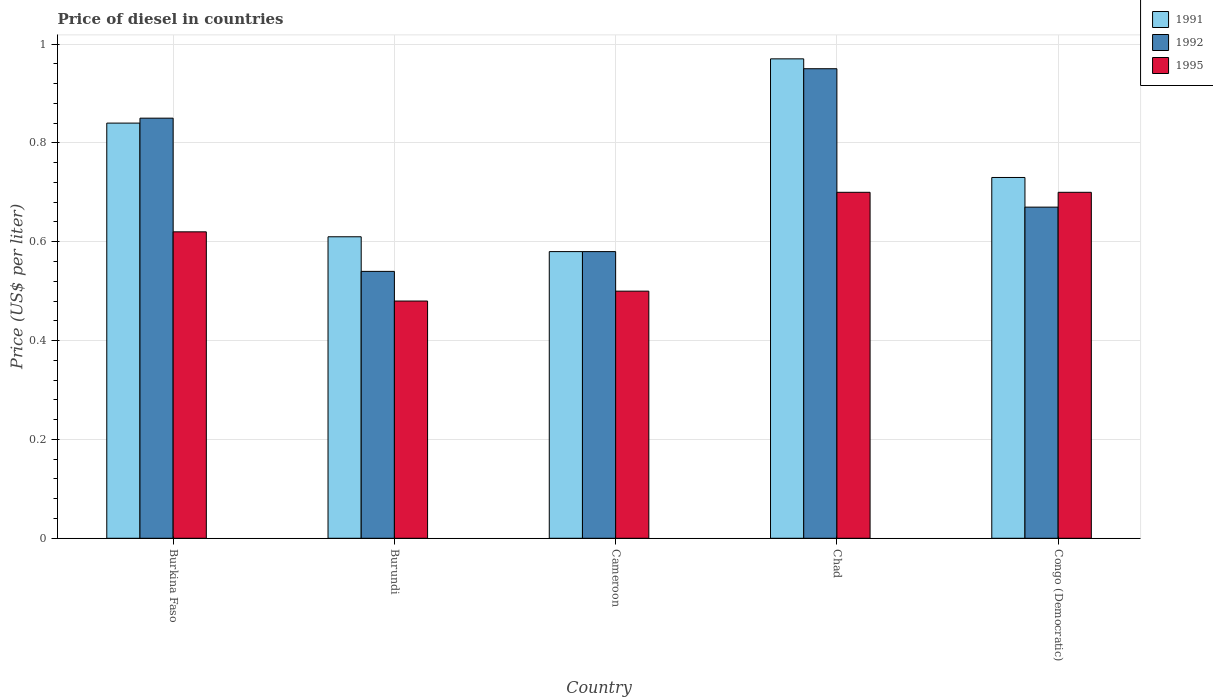Are the number of bars per tick equal to the number of legend labels?
Your answer should be very brief. Yes. Are the number of bars on each tick of the X-axis equal?
Keep it short and to the point. Yes. What is the label of the 5th group of bars from the left?
Offer a terse response. Congo (Democratic). What is the price of diesel in 1995 in Burkina Faso?
Make the answer very short. 0.62. Across all countries, what is the minimum price of diesel in 1992?
Your answer should be compact. 0.54. In which country was the price of diesel in 1995 maximum?
Your answer should be very brief. Chad. In which country was the price of diesel in 1992 minimum?
Give a very brief answer. Burundi. What is the total price of diesel in 1991 in the graph?
Offer a terse response. 3.73. What is the difference between the price of diesel in 1995 in Burkina Faso and that in Burundi?
Offer a very short reply. 0.14. What is the difference between the price of diesel in 1995 in Burundi and the price of diesel in 1992 in Cameroon?
Provide a short and direct response. -0.1. What is the average price of diesel in 1995 per country?
Keep it short and to the point. 0.6. What is the difference between the price of diesel of/in 1991 and price of diesel of/in 1995 in Congo (Democratic)?
Your answer should be very brief. 0.03. In how many countries, is the price of diesel in 1992 greater than 0.04 US$?
Your response must be concise. 5. What is the ratio of the price of diesel in 1992 in Burkina Faso to that in Cameroon?
Ensure brevity in your answer.  1.47. Is the price of diesel in 1995 in Burkina Faso less than that in Congo (Democratic)?
Ensure brevity in your answer.  Yes. What is the difference between the highest and the second highest price of diesel in 1991?
Provide a short and direct response. 0.13. What is the difference between the highest and the lowest price of diesel in 1995?
Keep it short and to the point. 0.22. Is the sum of the price of diesel in 1991 in Cameroon and Chad greater than the maximum price of diesel in 1992 across all countries?
Offer a very short reply. Yes. What does the 2nd bar from the right in Chad represents?
Your answer should be compact. 1992. Is it the case that in every country, the sum of the price of diesel in 1991 and price of diesel in 1995 is greater than the price of diesel in 1992?
Keep it short and to the point. Yes. How many bars are there?
Ensure brevity in your answer.  15. Does the graph contain grids?
Provide a short and direct response. Yes. How are the legend labels stacked?
Keep it short and to the point. Vertical. What is the title of the graph?
Offer a terse response. Price of diesel in countries. Does "1967" appear as one of the legend labels in the graph?
Your response must be concise. No. What is the label or title of the X-axis?
Provide a succinct answer. Country. What is the label or title of the Y-axis?
Make the answer very short. Price (US$ per liter). What is the Price (US$ per liter) of 1991 in Burkina Faso?
Provide a succinct answer. 0.84. What is the Price (US$ per liter) in 1995 in Burkina Faso?
Give a very brief answer. 0.62. What is the Price (US$ per liter) in 1991 in Burundi?
Provide a short and direct response. 0.61. What is the Price (US$ per liter) in 1992 in Burundi?
Your response must be concise. 0.54. What is the Price (US$ per liter) in 1995 in Burundi?
Your response must be concise. 0.48. What is the Price (US$ per liter) in 1991 in Cameroon?
Your response must be concise. 0.58. What is the Price (US$ per liter) of 1992 in Cameroon?
Make the answer very short. 0.58. What is the Price (US$ per liter) of 1992 in Chad?
Offer a terse response. 0.95. What is the Price (US$ per liter) of 1995 in Chad?
Offer a terse response. 0.7. What is the Price (US$ per liter) of 1991 in Congo (Democratic)?
Make the answer very short. 0.73. What is the Price (US$ per liter) in 1992 in Congo (Democratic)?
Keep it short and to the point. 0.67. What is the Price (US$ per liter) of 1995 in Congo (Democratic)?
Give a very brief answer. 0.7. Across all countries, what is the maximum Price (US$ per liter) in 1991?
Provide a succinct answer. 0.97. Across all countries, what is the maximum Price (US$ per liter) in 1992?
Offer a very short reply. 0.95. Across all countries, what is the minimum Price (US$ per liter) of 1991?
Ensure brevity in your answer.  0.58. Across all countries, what is the minimum Price (US$ per liter) of 1992?
Your answer should be very brief. 0.54. Across all countries, what is the minimum Price (US$ per liter) in 1995?
Provide a succinct answer. 0.48. What is the total Price (US$ per liter) in 1991 in the graph?
Give a very brief answer. 3.73. What is the total Price (US$ per liter) of 1992 in the graph?
Offer a very short reply. 3.59. What is the total Price (US$ per liter) in 1995 in the graph?
Offer a very short reply. 3. What is the difference between the Price (US$ per liter) in 1991 in Burkina Faso and that in Burundi?
Your answer should be compact. 0.23. What is the difference between the Price (US$ per liter) in 1992 in Burkina Faso and that in Burundi?
Offer a very short reply. 0.31. What is the difference between the Price (US$ per liter) in 1995 in Burkina Faso and that in Burundi?
Offer a very short reply. 0.14. What is the difference between the Price (US$ per liter) in 1991 in Burkina Faso and that in Cameroon?
Your answer should be compact. 0.26. What is the difference between the Price (US$ per liter) of 1992 in Burkina Faso and that in Cameroon?
Provide a succinct answer. 0.27. What is the difference between the Price (US$ per liter) of 1995 in Burkina Faso and that in Cameroon?
Offer a terse response. 0.12. What is the difference between the Price (US$ per liter) of 1991 in Burkina Faso and that in Chad?
Ensure brevity in your answer.  -0.13. What is the difference between the Price (US$ per liter) in 1995 in Burkina Faso and that in Chad?
Your answer should be very brief. -0.08. What is the difference between the Price (US$ per liter) of 1991 in Burkina Faso and that in Congo (Democratic)?
Your answer should be compact. 0.11. What is the difference between the Price (US$ per liter) of 1992 in Burkina Faso and that in Congo (Democratic)?
Provide a short and direct response. 0.18. What is the difference between the Price (US$ per liter) of 1995 in Burkina Faso and that in Congo (Democratic)?
Provide a succinct answer. -0.08. What is the difference between the Price (US$ per liter) in 1991 in Burundi and that in Cameroon?
Ensure brevity in your answer.  0.03. What is the difference between the Price (US$ per liter) in 1992 in Burundi and that in Cameroon?
Provide a short and direct response. -0.04. What is the difference between the Price (US$ per liter) in 1995 in Burundi and that in Cameroon?
Offer a very short reply. -0.02. What is the difference between the Price (US$ per liter) in 1991 in Burundi and that in Chad?
Your answer should be compact. -0.36. What is the difference between the Price (US$ per liter) of 1992 in Burundi and that in Chad?
Ensure brevity in your answer.  -0.41. What is the difference between the Price (US$ per liter) of 1995 in Burundi and that in Chad?
Offer a terse response. -0.22. What is the difference between the Price (US$ per liter) of 1991 in Burundi and that in Congo (Democratic)?
Your response must be concise. -0.12. What is the difference between the Price (US$ per liter) of 1992 in Burundi and that in Congo (Democratic)?
Ensure brevity in your answer.  -0.13. What is the difference between the Price (US$ per liter) of 1995 in Burundi and that in Congo (Democratic)?
Your answer should be compact. -0.22. What is the difference between the Price (US$ per liter) of 1991 in Cameroon and that in Chad?
Your answer should be very brief. -0.39. What is the difference between the Price (US$ per liter) in 1992 in Cameroon and that in Chad?
Make the answer very short. -0.37. What is the difference between the Price (US$ per liter) in 1995 in Cameroon and that in Chad?
Provide a short and direct response. -0.2. What is the difference between the Price (US$ per liter) in 1991 in Cameroon and that in Congo (Democratic)?
Ensure brevity in your answer.  -0.15. What is the difference between the Price (US$ per liter) in 1992 in Cameroon and that in Congo (Democratic)?
Your response must be concise. -0.09. What is the difference between the Price (US$ per liter) in 1991 in Chad and that in Congo (Democratic)?
Give a very brief answer. 0.24. What is the difference between the Price (US$ per liter) of 1992 in Chad and that in Congo (Democratic)?
Offer a terse response. 0.28. What is the difference between the Price (US$ per liter) of 1991 in Burkina Faso and the Price (US$ per liter) of 1995 in Burundi?
Your answer should be very brief. 0.36. What is the difference between the Price (US$ per liter) in 1992 in Burkina Faso and the Price (US$ per liter) in 1995 in Burundi?
Your answer should be compact. 0.37. What is the difference between the Price (US$ per liter) in 1991 in Burkina Faso and the Price (US$ per liter) in 1992 in Cameroon?
Provide a short and direct response. 0.26. What is the difference between the Price (US$ per liter) in 1991 in Burkina Faso and the Price (US$ per liter) in 1995 in Cameroon?
Keep it short and to the point. 0.34. What is the difference between the Price (US$ per liter) in 1991 in Burkina Faso and the Price (US$ per liter) in 1992 in Chad?
Provide a succinct answer. -0.11. What is the difference between the Price (US$ per liter) of 1991 in Burkina Faso and the Price (US$ per liter) of 1995 in Chad?
Offer a very short reply. 0.14. What is the difference between the Price (US$ per liter) in 1992 in Burkina Faso and the Price (US$ per liter) in 1995 in Chad?
Offer a very short reply. 0.15. What is the difference between the Price (US$ per liter) in 1991 in Burkina Faso and the Price (US$ per liter) in 1992 in Congo (Democratic)?
Your response must be concise. 0.17. What is the difference between the Price (US$ per liter) of 1991 in Burkina Faso and the Price (US$ per liter) of 1995 in Congo (Democratic)?
Ensure brevity in your answer.  0.14. What is the difference between the Price (US$ per liter) in 1991 in Burundi and the Price (US$ per liter) in 1992 in Cameroon?
Your answer should be very brief. 0.03. What is the difference between the Price (US$ per liter) in 1991 in Burundi and the Price (US$ per liter) in 1995 in Cameroon?
Offer a terse response. 0.11. What is the difference between the Price (US$ per liter) of 1992 in Burundi and the Price (US$ per liter) of 1995 in Cameroon?
Keep it short and to the point. 0.04. What is the difference between the Price (US$ per liter) of 1991 in Burundi and the Price (US$ per liter) of 1992 in Chad?
Your answer should be very brief. -0.34. What is the difference between the Price (US$ per liter) of 1991 in Burundi and the Price (US$ per liter) of 1995 in Chad?
Offer a very short reply. -0.09. What is the difference between the Price (US$ per liter) in 1992 in Burundi and the Price (US$ per liter) in 1995 in Chad?
Give a very brief answer. -0.16. What is the difference between the Price (US$ per liter) of 1991 in Burundi and the Price (US$ per liter) of 1992 in Congo (Democratic)?
Provide a short and direct response. -0.06. What is the difference between the Price (US$ per liter) of 1991 in Burundi and the Price (US$ per liter) of 1995 in Congo (Democratic)?
Keep it short and to the point. -0.09. What is the difference between the Price (US$ per liter) in 1992 in Burundi and the Price (US$ per liter) in 1995 in Congo (Democratic)?
Ensure brevity in your answer.  -0.16. What is the difference between the Price (US$ per liter) in 1991 in Cameroon and the Price (US$ per liter) in 1992 in Chad?
Provide a succinct answer. -0.37. What is the difference between the Price (US$ per liter) of 1991 in Cameroon and the Price (US$ per liter) of 1995 in Chad?
Your response must be concise. -0.12. What is the difference between the Price (US$ per liter) of 1992 in Cameroon and the Price (US$ per liter) of 1995 in Chad?
Keep it short and to the point. -0.12. What is the difference between the Price (US$ per liter) of 1991 in Cameroon and the Price (US$ per liter) of 1992 in Congo (Democratic)?
Give a very brief answer. -0.09. What is the difference between the Price (US$ per liter) of 1991 in Cameroon and the Price (US$ per liter) of 1995 in Congo (Democratic)?
Your response must be concise. -0.12. What is the difference between the Price (US$ per liter) in 1992 in Cameroon and the Price (US$ per liter) in 1995 in Congo (Democratic)?
Provide a succinct answer. -0.12. What is the difference between the Price (US$ per liter) of 1991 in Chad and the Price (US$ per liter) of 1992 in Congo (Democratic)?
Give a very brief answer. 0.3. What is the difference between the Price (US$ per liter) of 1991 in Chad and the Price (US$ per liter) of 1995 in Congo (Democratic)?
Provide a short and direct response. 0.27. What is the average Price (US$ per liter) in 1991 per country?
Provide a succinct answer. 0.75. What is the average Price (US$ per liter) in 1992 per country?
Give a very brief answer. 0.72. What is the average Price (US$ per liter) of 1995 per country?
Make the answer very short. 0.6. What is the difference between the Price (US$ per liter) in 1991 and Price (US$ per liter) in 1992 in Burkina Faso?
Your answer should be compact. -0.01. What is the difference between the Price (US$ per liter) of 1991 and Price (US$ per liter) of 1995 in Burkina Faso?
Make the answer very short. 0.22. What is the difference between the Price (US$ per liter) in 1992 and Price (US$ per liter) in 1995 in Burkina Faso?
Ensure brevity in your answer.  0.23. What is the difference between the Price (US$ per liter) of 1991 and Price (US$ per liter) of 1992 in Burundi?
Make the answer very short. 0.07. What is the difference between the Price (US$ per liter) in 1991 and Price (US$ per liter) in 1995 in Burundi?
Offer a terse response. 0.13. What is the difference between the Price (US$ per liter) of 1992 and Price (US$ per liter) of 1995 in Burundi?
Ensure brevity in your answer.  0.06. What is the difference between the Price (US$ per liter) of 1991 and Price (US$ per liter) of 1992 in Cameroon?
Give a very brief answer. 0. What is the difference between the Price (US$ per liter) of 1992 and Price (US$ per liter) of 1995 in Cameroon?
Make the answer very short. 0.08. What is the difference between the Price (US$ per liter) in 1991 and Price (US$ per liter) in 1995 in Chad?
Offer a very short reply. 0.27. What is the difference between the Price (US$ per liter) of 1991 and Price (US$ per liter) of 1992 in Congo (Democratic)?
Offer a terse response. 0.06. What is the difference between the Price (US$ per liter) in 1992 and Price (US$ per liter) in 1995 in Congo (Democratic)?
Your response must be concise. -0.03. What is the ratio of the Price (US$ per liter) of 1991 in Burkina Faso to that in Burundi?
Provide a succinct answer. 1.38. What is the ratio of the Price (US$ per liter) in 1992 in Burkina Faso to that in Burundi?
Offer a terse response. 1.57. What is the ratio of the Price (US$ per liter) of 1995 in Burkina Faso to that in Burundi?
Provide a short and direct response. 1.29. What is the ratio of the Price (US$ per liter) of 1991 in Burkina Faso to that in Cameroon?
Your response must be concise. 1.45. What is the ratio of the Price (US$ per liter) of 1992 in Burkina Faso to that in Cameroon?
Provide a succinct answer. 1.47. What is the ratio of the Price (US$ per liter) in 1995 in Burkina Faso to that in Cameroon?
Your response must be concise. 1.24. What is the ratio of the Price (US$ per liter) in 1991 in Burkina Faso to that in Chad?
Provide a succinct answer. 0.87. What is the ratio of the Price (US$ per liter) in 1992 in Burkina Faso to that in Chad?
Offer a very short reply. 0.89. What is the ratio of the Price (US$ per liter) of 1995 in Burkina Faso to that in Chad?
Keep it short and to the point. 0.89. What is the ratio of the Price (US$ per liter) of 1991 in Burkina Faso to that in Congo (Democratic)?
Your response must be concise. 1.15. What is the ratio of the Price (US$ per liter) of 1992 in Burkina Faso to that in Congo (Democratic)?
Your response must be concise. 1.27. What is the ratio of the Price (US$ per liter) of 1995 in Burkina Faso to that in Congo (Democratic)?
Offer a terse response. 0.89. What is the ratio of the Price (US$ per liter) of 1991 in Burundi to that in Cameroon?
Make the answer very short. 1.05. What is the ratio of the Price (US$ per liter) of 1995 in Burundi to that in Cameroon?
Offer a terse response. 0.96. What is the ratio of the Price (US$ per liter) of 1991 in Burundi to that in Chad?
Offer a very short reply. 0.63. What is the ratio of the Price (US$ per liter) in 1992 in Burundi to that in Chad?
Your answer should be very brief. 0.57. What is the ratio of the Price (US$ per liter) of 1995 in Burundi to that in Chad?
Provide a succinct answer. 0.69. What is the ratio of the Price (US$ per liter) in 1991 in Burundi to that in Congo (Democratic)?
Keep it short and to the point. 0.84. What is the ratio of the Price (US$ per liter) of 1992 in Burundi to that in Congo (Democratic)?
Your response must be concise. 0.81. What is the ratio of the Price (US$ per liter) in 1995 in Burundi to that in Congo (Democratic)?
Ensure brevity in your answer.  0.69. What is the ratio of the Price (US$ per liter) in 1991 in Cameroon to that in Chad?
Ensure brevity in your answer.  0.6. What is the ratio of the Price (US$ per liter) of 1992 in Cameroon to that in Chad?
Your response must be concise. 0.61. What is the ratio of the Price (US$ per liter) in 1995 in Cameroon to that in Chad?
Your answer should be very brief. 0.71. What is the ratio of the Price (US$ per liter) in 1991 in Cameroon to that in Congo (Democratic)?
Offer a terse response. 0.79. What is the ratio of the Price (US$ per liter) of 1992 in Cameroon to that in Congo (Democratic)?
Give a very brief answer. 0.87. What is the ratio of the Price (US$ per liter) in 1995 in Cameroon to that in Congo (Democratic)?
Your response must be concise. 0.71. What is the ratio of the Price (US$ per liter) of 1991 in Chad to that in Congo (Democratic)?
Offer a very short reply. 1.33. What is the ratio of the Price (US$ per liter) of 1992 in Chad to that in Congo (Democratic)?
Provide a succinct answer. 1.42. What is the difference between the highest and the second highest Price (US$ per liter) in 1991?
Your response must be concise. 0.13. What is the difference between the highest and the second highest Price (US$ per liter) in 1992?
Ensure brevity in your answer.  0.1. What is the difference between the highest and the second highest Price (US$ per liter) in 1995?
Make the answer very short. 0. What is the difference between the highest and the lowest Price (US$ per liter) in 1991?
Your answer should be compact. 0.39. What is the difference between the highest and the lowest Price (US$ per liter) of 1992?
Provide a succinct answer. 0.41. What is the difference between the highest and the lowest Price (US$ per liter) of 1995?
Offer a terse response. 0.22. 